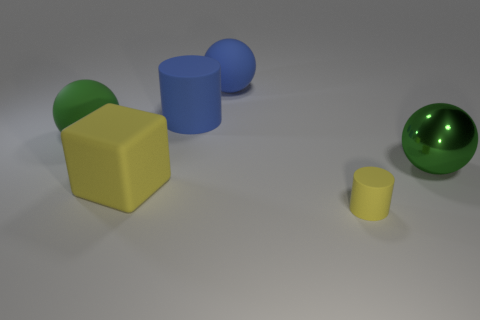What is the material of the big green object on the right side of the green ball that is to the left of the large blue rubber ball?
Offer a terse response. Metal. What is the object that is to the right of the tiny yellow matte cylinder made of?
Give a very brief answer. Metal. What number of other green objects are the same shape as the large green metallic thing?
Ensure brevity in your answer.  1. Does the small rubber thing have the same color as the cube?
Give a very brief answer. Yes. What is the green ball that is on the right side of the matte cylinder behind the green ball that is right of the tiny thing made of?
Your answer should be very brief. Metal. There is a tiny thing; are there any things behind it?
Ensure brevity in your answer.  Yes. There is a yellow object that is the same size as the green shiny object; what is its shape?
Your answer should be very brief. Cube. What number of rubber objects are spheres or blue objects?
Provide a succinct answer. 3. There is another object that is the same color as the shiny thing; what is its shape?
Provide a short and direct response. Sphere. Does the rubber ball that is right of the big rubber cube have the same color as the big rubber cylinder?
Give a very brief answer. Yes. 